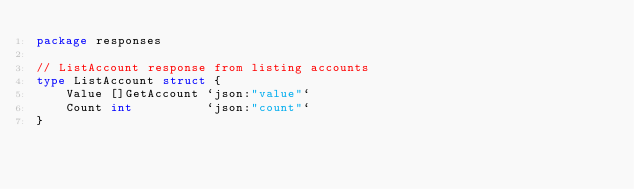Convert code to text. <code><loc_0><loc_0><loc_500><loc_500><_Go_>package responses

// ListAccount response from listing accounts
type ListAccount struct {
	Value []GetAccount `json:"value"`
	Count int          `json:"count"`
}
</code> 